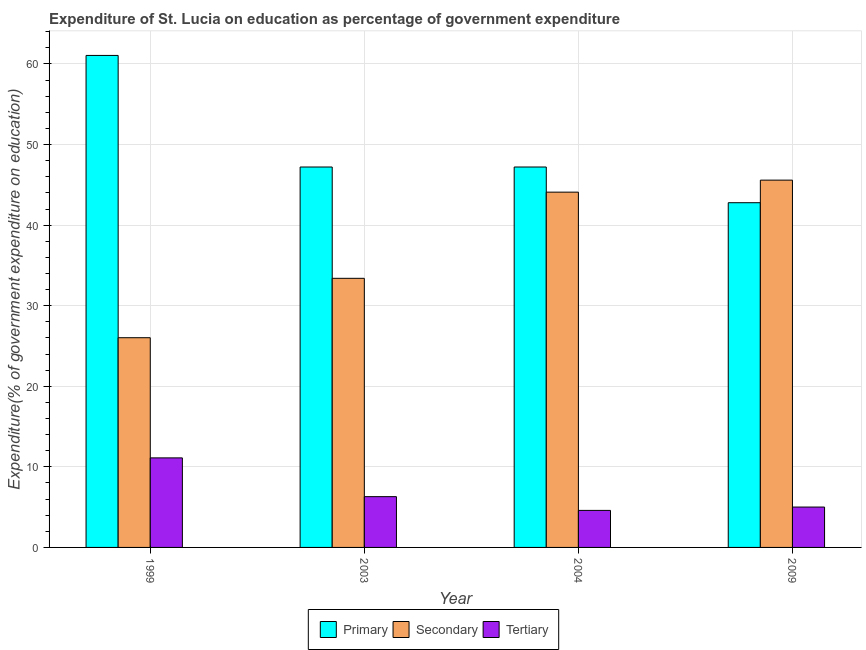Are the number of bars per tick equal to the number of legend labels?
Provide a short and direct response. Yes. How many bars are there on the 1st tick from the right?
Offer a terse response. 3. What is the label of the 3rd group of bars from the left?
Give a very brief answer. 2004. In how many cases, is the number of bars for a given year not equal to the number of legend labels?
Provide a short and direct response. 0. What is the expenditure on primary education in 2003?
Offer a very short reply. 47.21. Across all years, what is the maximum expenditure on primary education?
Make the answer very short. 61.06. Across all years, what is the minimum expenditure on secondary education?
Ensure brevity in your answer.  26.03. In which year was the expenditure on tertiary education minimum?
Ensure brevity in your answer.  2004. What is the total expenditure on secondary education in the graph?
Give a very brief answer. 149.1. What is the difference between the expenditure on primary education in 2004 and that in 2009?
Offer a terse response. 4.43. What is the difference between the expenditure on primary education in 1999 and the expenditure on secondary education in 2003?
Keep it short and to the point. 13.85. What is the average expenditure on secondary education per year?
Offer a terse response. 37.28. In the year 2003, what is the difference between the expenditure on secondary education and expenditure on primary education?
Give a very brief answer. 0. What is the ratio of the expenditure on secondary education in 2003 to that in 2009?
Provide a short and direct response. 0.73. Is the expenditure on secondary education in 2004 less than that in 2009?
Offer a terse response. Yes. What is the difference between the highest and the second highest expenditure on tertiary education?
Your answer should be compact. 4.81. What is the difference between the highest and the lowest expenditure on primary education?
Keep it short and to the point. 18.28. Is the sum of the expenditure on secondary education in 1999 and 2009 greater than the maximum expenditure on tertiary education across all years?
Ensure brevity in your answer.  Yes. What does the 2nd bar from the left in 2009 represents?
Ensure brevity in your answer.  Secondary. What does the 2nd bar from the right in 2003 represents?
Provide a succinct answer. Secondary. Is it the case that in every year, the sum of the expenditure on primary education and expenditure on secondary education is greater than the expenditure on tertiary education?
Your answer should be very brief. Yes. Are all the bars in the graph horizontal?
Your response must be concise. No. What is the difference between two consecutive major ticks on the Y-axis?
Provide a short and direct response. 10. Does the graph contain any zero values?
Your response must be concise. No. What is the title of the graph?
Your answer should be very brief. Expenditure of St. Lucia on education as percentage of government expenditure. Does "Self-employed" appear as one of the legend labels in the graph?
Offer a terse response. No. What is the label or title of the X-axis?
Provide a succinct answer. Year. What is the label or title of the Y-axis?
Provide a succinct answer. Expenditure(% of government expenditure on education). What is the Expenditure(% of government expenditure on education) in Primary in 1999?
Provide a succinct answer. 61.06. What is the Expenditure(% of government expenditure on education) in Secondary in 1999?
Ensure brevity in your answer.  26.03. What is the Expenditure(% of government expenditure on education) in Tertiary in 1999?
Provide a succinct answer. 11.11. What is the Expenditure(% of government expenditure on education) in Primary in 2003?
Offer a very short reply. 47.21. What is the Expenditure(% of government expenditure on education) of Secondary in 2003?
Provide a short and direct response. 33.4. What is the Expenditure(% of government expenditure on education) in Tertiary in 2003?
Your answer should be compact. 6.3. What is the Expenditure(% of government expenditure on education) in Primary in 2004?
Make the answer very short. 47.21. What is the Expenditure(% of government expenditure on education) in Secondary in 2004?
Make the answer very short. 44.09. What is the Expenditure(% of government expenditure on education) of Tertiary in 2004?
Offer a terse response. 4.6. What is the Expenditure(% of government expenditure on education) in Primary in 2009?
Your response must be concise. 42.78. What is the Expenditure(% of government expenditure on education) of Secondary in 2009?
Offer a very short reply. 45.58. What is the Expenditure(% of government expenditure on education) in Tertiary in 2009?
Offer a terse response. 5.01. Across all years, what is the maximum Expenditure(% of government expenditure on education) of Primary?
Your response must be concise. 61.06. Across all years, what is the maximum Expenditure(% of government expenditure on education) of Secondary?
Your answer should be very brief. 45.58. Across all years, what is the maximum Expenditure(% of government expenditure on education) in Tertiary?
Your response must be concise. 11.11. Across all years, what is the minimum Expenditure(% of government expenditure on education) of Primary?
Give a very brief answer. 42.78. Across all years, what is the minimum Expenditure(% of government expenditure on education) in Secondary?
Keep it short and to the point. 26.03. Across all years, what is the minimum Expenditure(% of government expenditure on education) in Tertiary?
Ensure brevity in your answer.  4.6. What is the total Expenditure(% of government expenditure on education) in Primary in the graph?
Provide a succinct answer. 198.27. What is the total Expenditure(% of government expenditure on education) in Secondary in the graph?
Ensure brevity in your answer.  149.1. What is the total Expenditure(% of government expenditure on education) in Tertiary in the graph?
Provide a short and direct response. 27.02. What is the difference between the Expenditure(% of government expenditure on education) in Primary in 1999 and that in 2003?
Offer a terse response. 13.85. What is the difference between the Expenditure(% of government expenditure on education) of Secondary in 1999 and that in 2003?
Ensure brevity in your answer.  -7.37. What is the difference between the Expenditure(% of government expenditure on education) of Tertiary in 1999 and that in 2003?
Your answer should be very brief. 4.81. What is the difference between the Expenditure(% of government expenditure on education) of Primary in 1999 and that in 2004?
Offer a very short reply. 13.85. What is the difference between the Expenditure(% of government expenditure on education) of Secondary in 1999 and that in 2004?
Keep it short and to the point. -18.07. What is the difference between the Expenditure(% of government expenditure on education) in Tertiary in 1999 and that in 2004?
Provide a succinct answer. 6.52. What is the difference between the Expenditure(% of government expenditure on education) in Primary in 1999 and that in 2009?
Your answer should be very brief. 18.28. What is the difference between the Expenditure(% of government expenditure on education) of Secondary in 1999 and that in 2009?
Your response must be concise. -19.56. What is the difference between the Expenditure(% of government expenditure on education) in Tertiary in 1999 and that in 2009?
Offer a terse response. 6.1. What is the difference between the Expenditure(% of government expenditure on education) of Secondary in 2003 and that in 2004?
Ensure brevity in your answer.  -10.69. What is the difference between the Expenditure(% of government expenditure on education) in Tertiary in 2003 and that in 2004?
Your answer should be very brief. 1.71. What is the difference between the Expenditure(% of government expenditure on education) of Primary in 2003 and that in 2009?
Your response must be concise. 4.43. What is the difference between the Expenditure(% of government expenditure on education) in Secondary in 2003 and that in 2009?
Give a very brief answer. -12.19. What is the difference between the Expenditure(% of government expenditure on education) in Tertiary in 2003 and that in 2009?
Ensure brevity in your answer.  1.29. What is the difference between the Expenditure(% of government expenditure on education) of Primary in 2004 and that in 2009?
Keep it short and to the point. 4.43. What is the difference between the Expenditure(% of government expenditure on education) in Secondary in 2004 and that in 2009?
Your answer should be very brief. -1.49. What is the difference between the Expenditure(% of government expenditure on education) of Tertiary in 2004 and that in 2009?
Your response must be concise. -0.42. What is the difference between the Expenditure(% of government expenditure on education) in Primary in 1999 and the Expenditure(% of government expenditure on education) in Secondary in 2003?
Give a very brief answer. 27.66. What is the difference between the Expenditure(% of government expenditure on education) in Primary in 1999 and the Expenditure(% of government expenditure on education) in Tertiary in 2003?
Give a very brief answer. 54.76. What is the difference between the Expenditure(% of government expenditure on education) in Secondary in 1999 and the Expenditure(% of government expenditure on education) in Tertiary in 2003?
Your answer should be very brief. 19.73. What is the difference between the Expenditure(% of government expenditure on education) of Primary in 1999 and the Expenditure(% of government expenditure on education) of Secondary in 2004?
Give a very brief answer. 16.97. What is the difference between the Expenditure(% of government expenditure on education) of Primary in 1999 and the Expenditure(% of government expenditure on education) of Tertiary in 2004?
Provide a succinct answer. 56.47. What is the difference between the Expenditure(% of government expenditure on education) of Secondary in 1999 and the Expenditure(% of government expenditure on education) of Tertiary in 2004?
Offer a terse response. 21.43. What is the difference between the Expenditure(% of government expenditure on education) of Primary in 1999 and the Expenditure(% of government expenditure on education) of Secondary in 2009?
Make the answer very short. 15.48. What is the difference between the Expenditure(% of government expenditure on education) in Primary in 1999 and the Expenditure(% of government expenditure on education) in Tertiary in 2009?
Offer a terse response. 56.05. What is the difference between the Expenditure(% of government expenditure on education) of Secondary in 1999 and the Expenditure(% of government expenditure on education) of Tertiary in 2009?
Provide a short and direct response. 21.02. What is the difference between the Expenditure(% of government expenditure on education) of Primary in 2003 and the Expenditure(% of government expenditure on education) of Secondary in 2004?
Provide a succinct answer. 3.12. What is the difference between the Expenditure(% of government expenditure on education) of Primary in 2003 and the Expenditure(% of government expenditure on education) of Tertiary in 2004?
Provide a short and direct response. 42.62. What is the difference between the Expenditure(% of government expenditure on education) in Secondary in 2003 and the Expenditure(% of government expenditure on education) in Tertiary in 2004?
Provide a succinct answer. 28.8. What is the difference between the Expenditure(% of government expenditure on education) of Primary in 2003 and the Expenditure(% of government expenditure on education) of Secondary in 2009?
Provide a succinct answer. 1.63. What is the difference between the Expenditure(% of government expenditure on education) in Primary in 2003 and the Expenditure(% of government expenditure on education) in Tertiary in 2009?
Your answer should be very brief. 42.2. What is the difference between the Expenditure(% of government expenditure on education) of Secondary in 2003 and the Expenditure(% of government expenditure on education) of Tertiary in 2009?
Provide a short and direct response. 28.39. What is the difference between the Expenditure(% of government expenditure on education) of Primary in 2004 and the Expenditure(% of government expenditure on education) of Secondary in 2009?
Your response must be concise. 1.63. What is the difference between the Expenditure(% of government expenditure on education) in Primary in 2004 and the Expenditure(% of government expenditure on education) in Tertiary in 2009?
Ensure brevity in your answer.  42.2. What is the difference between the Expenditure(% of government expenditure on education) of Secondary in 2004 and the Expenditure(% of government expenditure on education) of Tertiary in 2009?
Offer a terse response. 39.08. What is the average Expenditure(% of government expenditure on education) of Primary per year?
Your answer should be compact. 49.57. What is the average Expenditure(% of government expenditure on education) of Secondary per year?
Give a very brief answer. 37.28. What is the average Expenditure(% of government expenditure on education) in Tertiary per year?
Your answer should be compact. 6.76. In the year 1999, what is the difference between the Expenditure(% of government expenditure on education) of Primary and Expenditure(% of government expenditure on education) of Secondary?
Offer a very short reply. 35.03. In the year 1999, what is the difference between the Expenditure(% of government expenditure on education) of Primary and Expenditure(% of government expenditure on education) of Tertiary?
Your answer should be very brief. 49.95. In the year 1999, what is the difference between the Expenditure(% of government expenditure on education) in Secondary and Expenditure(% of government expenditure on education) in Tertiary?
Provide a short and direct response. 14.91. In the year 2003, what is the difference between the Expenditure(% of government expenditure on education) of Primary and Expenditure(% of government expenditure on education) of Secondary?
Your response must be concise. 13.81. In the year 2003, what is the difference between the Expenditure(% of government expenditure on education) of Primary and Expenditure(% of government expenditure on education) of Tertiary?
Ensure brevity in your answer.  40.91. In the year 2003, what is the difference between the Expenditure(% of government expenditure on education) of Secondary and Expenditure(% of government expenditure on education) of Tertiary?
Provide a short and direct response. 27.1. In the year 2004, what is the difference between the Expenditure(% of government expenditure on education) in Primary and Expenditure(% of government expenditure on education) in Secondary?
Offer a very short reply. 3.12. In the year 2004, what is the difference between the Expenditure(% of government expenditure on education) in Primary and Expenditure(% of government expenditure on education) in Tertiary?
Ensure brevity in your answer.  42.62. In the year 2004, what is the difference between the Expenditure(% of government expenditure on education) of Secondary and Expenditure(% of government expenditure on education) of Tertiary?
Provide a short and direct response. 39.5. In the year 2009, what is the difference between the Expenditure(% of government expenditure on education) of Primary and Expenditure(% of government expenditure on education) of Secondary?
Ensure brevity in your answer.  -2.8. In the year 2009, what is the difference between the Expenditure(% of government expenditure on education) in Primary and Expenditure(% of government expenditure on education) in Tertiary?
Keep it short and to the point. 37.77. In the year 2009, what is the difference between the Expenditure(% of government expenditure on education) of Secondary and Expenditure(% of government expenditure on education) of Tertiary?
Provide a succinct answer. 40.57. What is the ratio of the Expenditure(% of government expenditure on education) in Primary in 1999 to that in 2003?
Give a very brief answer. 1.29. What is the ratio of the Expenditure(% of government expenditure on education) in Secondary in 1999 to that in 2003?
Your response must be concise. 0.78. What is the ratio of the Expenditure(% of government expenditure on education) of Tertiary in 1999 to that in 2003?
Your answer should be very brief. 1.76. What is the ratio of the Expenditure(% of government expenditure on education) of Primary in 1999 to that in 2004?
Offer a very short reply. 1.29. What is the ratio of the Expenditure(% of government expenditure on education) in Secondary in 1999 to that in 2004?
Provide a short and direct response. 0.59. What is the ratio of the Expenditure(% of government expenditure on education) of Tertiary in 1999 to that in 2004?
Your response must be concise. 2.42. What is the ratio of the Expenditure(% of government expenditure on education) in Primary in 1999 to that in 2009?
Offer a terse response. 1.43. What is the ratio of the Expenditure(% of government expenditure on education) in Secondary in 1999 to that in 2009?
Give a very brief answer. 0.57. What is the ratio of the Expenditure(% of government expenditure on education) of Tertiary in 1999 to that in 2009?
Offer a very short reply. 2.22. What is the ratio of the Expenditure(% of government expenditure on education) in Primary in 2003 to that in 2004?
Provide a succinct answer. 1. What is the ratio of the Expenditure(% of government expenditure on education) of Secondary in 2003 to that in 2004?
Offer a very short reply. 0.76. What is the ratio of the Expenditure(% of government expenditure on education) of Tertiary in 2003 to that in 2004?
Your answer should be compact. 1.37. What is the ratio of the Expenditure(% of government expenditure on education) in Primary in 2003 to that in 2009?
Keep it short and to the point. 1.1. What is the ratio of the Expenditure(% of government expenditure on education) in Secondary in 2003 to that in 2009?
Make the answer very short. 0.73. What is the ratio of the Expenditure(% of government expenditure on education) in Tertiary in 2003 to that in 2009?
Offer a very short reply. 1.26. What is the ratio of the Expenditure(% of government expenditure on education) of Primary in 2004 to that in 2009?
Your answer should be very brief. 1.1. What is the ratio of the Expenditure(% of government expenditure on education) of Secondary in 2004 to that in 2009?
Make the answer very short. 0.97. What is the ratio of the Expenditure(% of government expenditure on education) of Tertiary in 2004 to that in 2009?
Your response must be concise. 0.92. What is the difference between the highest and the second highest Expenditure(% of government expenditure on education) in Primary?
Keep it short and to the point. 13.85. What is the difference between the highest and the second highest Expenditure(% of government expenditure on education) of Secondary?
Ensure brevity in your answer.  1.49. What is the difference between the highest and the second highest Expenditure(% of government expenditure on education) in Tertiary?
Give a very brief answer. 4.81. What is the difference between the highest and the lowest Expenditure(% of government expenditure on education) of Primary?
Your answer should be compact. 18.28. What is the difference between the highest and the lowest Expenditure(% of government expenditure on education) of Secondary?
Your answer should be very brief. 19.56. What is the difference between the highest and the lowest Expenditure(% of government expenditure on education) in Tertiary?
Your answer should be compact. 6.52. 